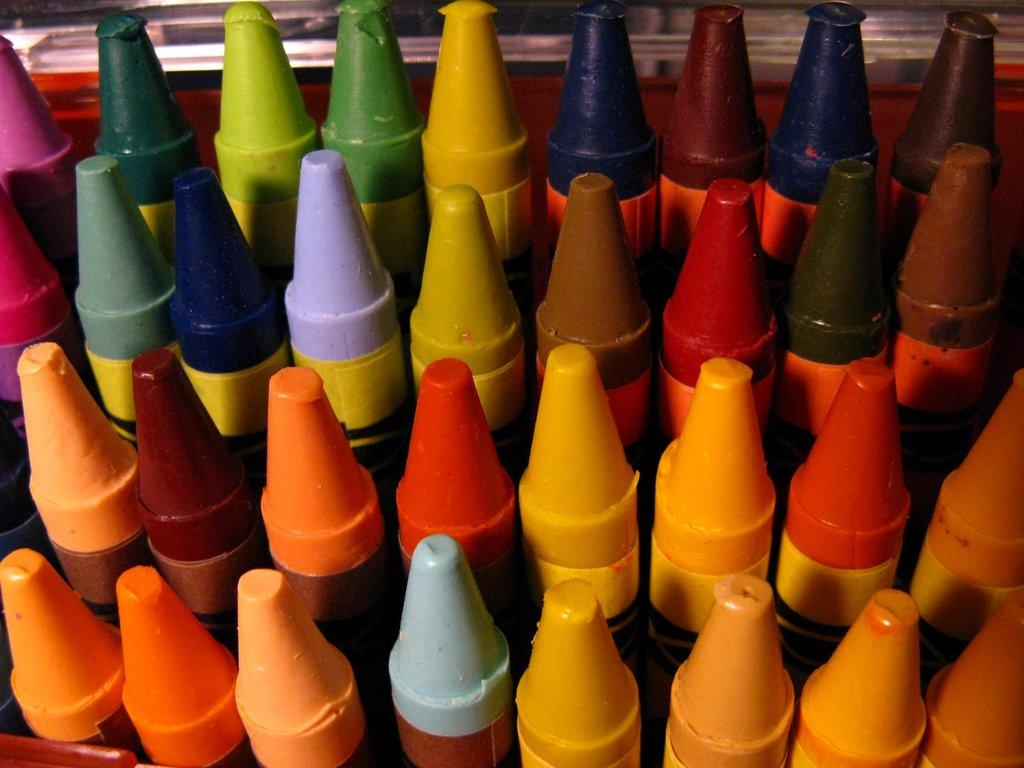What objects can be seen in the image? There are crayons in the image. What might the crayons be used for? The crayons might be used for drawing or coloring. Are the crayons arranged in any particular way? The facts provided do not specify how the crayons are arranged. What type of vegetable is growing on the island in the image? There is no island or vegetable present in the image; it only features crayons. 